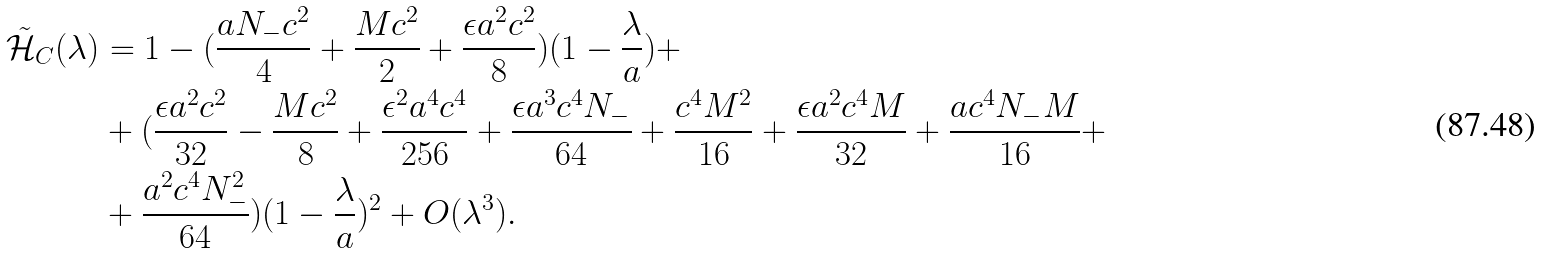<formula> <loc_0><loc_0><loc_500><loc_500>\tilde { \mathcal { H } } _ { C } ( \lambda ) & = 1 - ( \frac { a N _ { - } c ^ { 2 } } { 4 } + \frac { M c ^ { 2 } } { 2 } + \frac { \epsilon a ^ { 2 } c ^ { 2 } } { 8 } ) ( 1 - \frac { \lambda } { a } ) + \\ & + ( \frac { \epsilon a ^ { 2 } c ^ { 2 } } { 3 2 } - \frac { M c ^ { 2 } } { 8 } + \frac { \epsilon ^ { 2 } a ^ { 4 } c ^ { 4 } } { 2 5 6 } + \frac { \epsilon a ^ { 3 } c ^ { 4 } N _ { - } } { 6 4 } + \frac { c ^ { 4 } M ^ { 2 } } { 1 6 } + \frac { \epsilon a ^ { 2 } c ^ { 4 } M } { 3 2 } + \frac { a c ^ { 4 } N _ { - } M } { 1 6 } + \\ & + \frac { a ^ { 2 } c ^ { 4 } N _ { - } ^ { 2 } } { 6 4 } ) ( 1 - \frac { \lambda } { a } ) ^ { 2 } + O ( \lambda ^ { 3 } ) .</formula> 